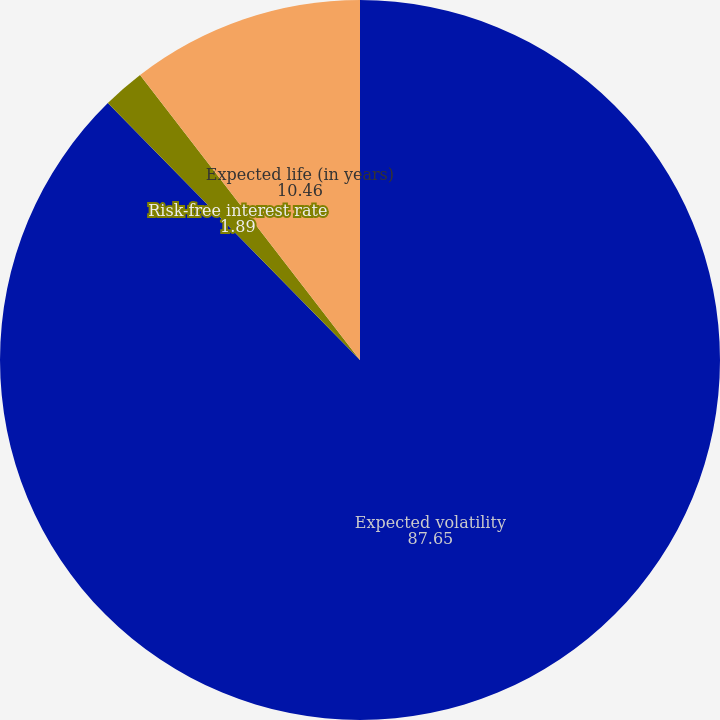Convert chart. <chart><loc_0><loc_0><loc_500><loc_500><pie_chart><fcel>Expected volatility<fcel>Risk-free interest rate<fcel>Expected life (in years)<nl><fcel>87.65%<fcel>1.89%<fcel>10.46%<nl></chart> 